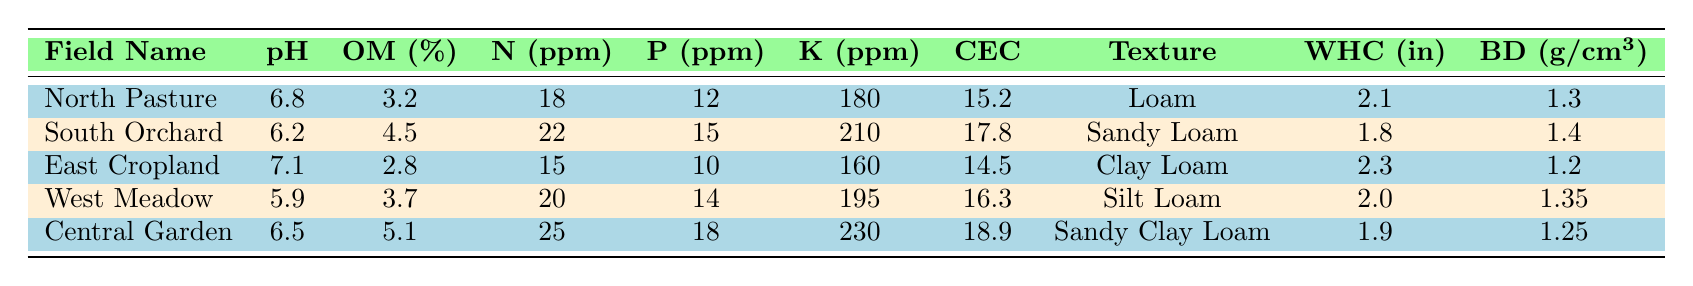What is the soil pH in the East Cropland? The table shows that the soil pH for East Cropland is 7.1.
Answer: 7.1 Which field has the highest percentage of organic matter? Looking at the organic matter percentage column, Central Garden has 5.1%, which is the highest among all fields.
Answer: Central Garden What is the nitrogen level in the South Orchard? The nitrogen level (N ppm) in the South Orchard is given as 22 ppm in the table.
Answer: 22 ppm What is the average potassium level across all fields? To find the average potassium level, add the potassium values: 180 + 210 + 160 + 195 + 230 = 1075. Then divide by the number of fields (5): 1075 / 5 = 215.
Answer: 215 ppm Is the phosphorus level higher in the North Pasture than in the West Meadow? North Pasture has 12 ppm of phosphorus, while West Meadow has 14 ppm. Since 12 is less than 14, the statement is false.
Answer: No What is the cation exchange capacity for the field with the lowest bulk density? The field with the lowest bulk density is East Cropland with 1.2 g/cm³, and its cation exchange capacity is 14.5.
Answer: 14.5 Which field has the best water holding capacity, and what is its value? The water holding capacity (WHC) is highest in East Cropland at 2.3 inches compared to the others listed.
Answer: East Cropland, 2.3 inches If you sum the phosphorus levels of the North Pasture and Central Garden, what is the total? North Pasture has 12 ppm and Central Garden has 18 ppm. Adding these gives 12 + 18 = 30 ppm.
Answer: 30 ppm Is there a field with a pH below 6.0? The table shows that the lowest pH is 5.9 in West Meadow, which is below 6.0.
Answer: Yes Which soil texture is found in the South Orchard? The table states that the soil texture of the South Orchard is "Sandy Loam."
Answer: Sandy Loam 